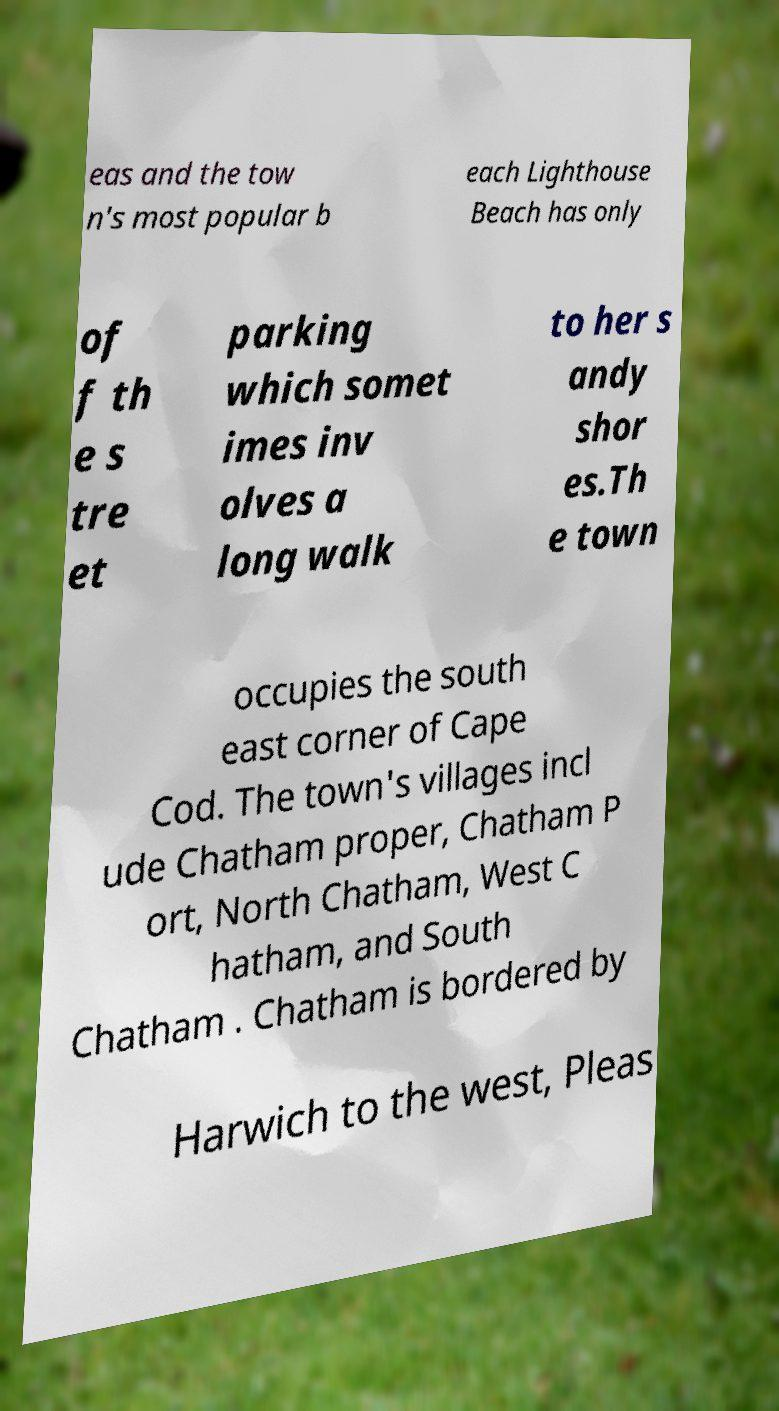Can you accurately transcribe the text from the provided image for me? eas and the tow n's most popular b each Lighthouse Beach has only of f th e s tre et parking which somet imes inv olves a long walk to her s andy shor es.Th e town occupies the south east corner of Cape Cod. The town's villages incl ude Chatham proper, Chatham P ort, North Chatham, West C hatham, and South Chatham . Chatham is bordered by Harwich to the west, Pleas 